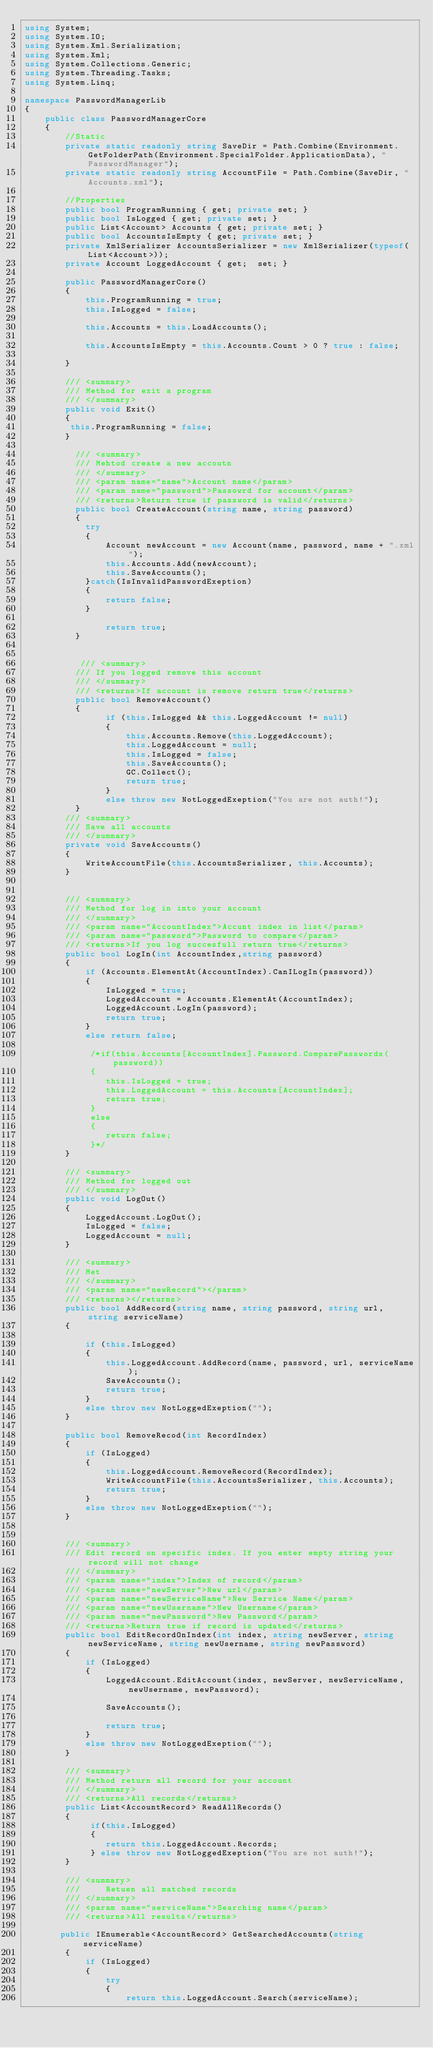<code> <loc_0><loc_0><loc_500><loc_500><_C#_>using System;
using System.IO;
using System.Xml.Serialization;
using System.Xml;
using System.Collections.Generic;
using System.Threading.Tasks;
using System.Linq;

namespace PasswordManagerLib
{
    public class PasswordManagerCore
    {
        //Static 
        private static readonly string SaveDir = Path.Combine(Environment.GetFolderPath(Environment.SpecialFolder.ApplicationData), "PasswordManager");
        private static readonly string AccountFile = Path.Combine(SaveDir, "Accounts.xml");

        //Properties
        public bool ProgramRunning { get; private set; }
        public bool IsLogged { get; private set; }
        public List<Account> Accounts { get; private set; }
        public bool AccountsIsEmpty { get; private set; }
        private XmlSerializer AccountsSerializer = new XmlSerializer(typeof(List<Account>));
        private Account LoggedAccount { get;  set; }

        public PasswordManagerCore()
        {
            this.ProgramRunning = true;
            this.IsLogged = false;

            this.Accounts = this.LoadAccounts();

            this.AccountsIsEmpty = this.Accounts.Count > 0 ? true : false;

        } 

        /// <summary>
        /// Method for exit a program
        /// </summary>
        public void Exit()
        {
         this.ProgramRunning = false;
        }

          /// <summary>
          /// Mehtod create a new accoutn
          /// </summary>
          /// <param name="name">Account name</param>
          /// <param name="password">Passowrd for account</param>
          /// <returns>Return true if password is valid</returns>
          public bool CreateAccount(string name, string password)
          {
            try
            {
                Account newAccount = new Account(name, password, name + ".xml");
                this.Accounts.Add(newAccount);
                this.SaveAccounts();
            }catch(IsInvalidPasswordExeption)
            {
                return false;
            }

                return true;
          }


           /// <summary>
          /// If you logged remove this account
          /// </summary>
          /// <returns>If account is remove return true</returns>
          public bool RemoveAccount()
          {
                if (this.IsLogged && this.LoggedAccount != null)
                {
                    this.Accounts.Remove(this.LoggedAccount);
                    this.LoggedAccount = null;
                    this.IsLogged = false;
                    this.SaveAccounts();
                    GC.Collect();
                    return true;
                }
                else throw new NotLoggedExeption("You are not auth!");
          }
        /// <summary>
        /// Save all accounts
        /// </summary>
        private void SaveAccounts()
        {
            WriteAccountFile(this.AccountsSerializer, this.Accounts);
        }


        /// <summary>
        /// Method for log in into your account
        /// </summary>
        /// <param name="AccountIndex">Accunt index in list</param>
        /// <param name="password">Password to compare</param>
        /// <returns>If you log succesfull return true</returns>
        public bool LogIn(int AccountIndex,string password)
        {
            if (Accounts.ElementAt(AccountIndex).CanILogIn(password))
            {
                IsLogged = true;
                LoggedAccount = Accounts.ElementAt(AccountIndex);
                LoggedAccount.LogIn(password);
                return true;
            }
            else return false;

             /*if(this.Accounts[AccountIndex].Password.ComparePasswords(password))
             {
                this.IsLogged = true;
                this.LoggedAccount = this.Accounts[AccountIndex];
                return true;
             }
             else
             {
                return false;
             }*/
        }

        /// <summary>
        /// Method for logged out
        /// </summary>
        public void LogOut()
        {
            LoggedAccount.LogOut();
            IsLogged = false;
            LoggedAccount = null;
        }

        /// <summary>
        /// Met
        /// </summary>
        /// <param name="newRecord"></param>
        /// <returns></returns>
        public bool AddRecord(string name, string password, string url, string serviceName)
        {   

            if (this.IsLogged)
            {
                this.LoggedAccount.AddRecord(name, password, url, serviceName);
                SaveAccounts();
                return true;
            }
            else throw new NotLoggedExeption("");
        }

        public bool RemoveRecod(int RecordIndex)
        {
            if (IsLogged)
            {
                this.LoggedAccount.RemoveRecord(RecordIndex);
                WriteAccountFile(this.AccountsSerializer, this.Accounts);
                return true;
            }
            else throw new NotLoggedExeption("");
        }


        /// <summary>
        /// Edit record on specific index. If you enter empty string your record will not change
        /// </summary>
        /// <param name="index">Index of record</param>
        /// <param name="newServer">New url</param>
        /// <param name="newServiceName">New Service Name</param>
        /// <param name="newUsername">New Username</param>
        /// <param name="newPassword">New Password</param>
        /// <returns>Return true if record is updated</returns>
        public bool EditRecordOnIndex(int index, string newServer, string newServiceName, string newUsername, string newPassword)
        {
            if (IsLogged)
            {
                LoggedAccount.EditAccount(index, newServer, newServiceName, newUsername, newPassword);

                SaveAccounts();

                return true;
            }
            else throw new NotLoggedExeption("");
        }

        /// <summary>
        /// Method return all record for your account
        /// </summary>
        /// <returns>All records</returns>
        public List<AccountRecord> ReadAllRecords()
        {
             if(this.IsLogged)
             {
                return this.LoggedAccount.Records;
             } else throw new NotLoggedExeption("You are not auth!");
        }

        /// <summary>
        ///     Retuen all matched records
        /// </summary>
        /// <param name="serviceName">Searching name</param>
        /// <returns>All results</returns>

       public IEnumerable<AccountRecord> GetSearchedAccounts(string serviceName)
        {
            if (IsLogged)
            {
                try
                {
                    return this.LoggedAccount.Search(serviceName);
</code> 